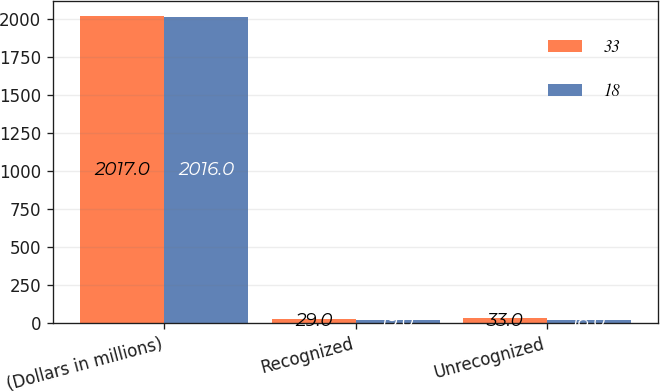Convert chart. <chart><loc_0><loc_0><loc_500><loc_500><stacked_bar_chart><ecel><fcel>(Dollars in millions)<fcel>Recognized<fcel>Unrecognized<nl><fcel>33<fcel>2017<fcel>29<fcel>33<nl><fcel>18<fcel>2016<fcel>19<fcel>18<nl></chart> 